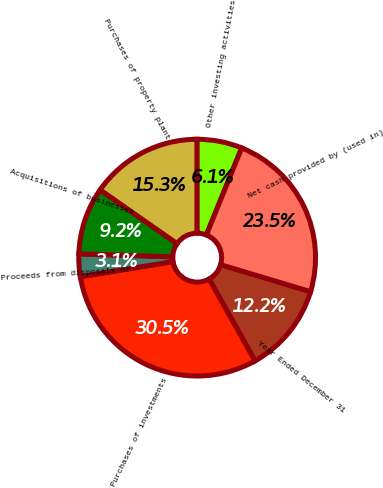Convert chart. <chart><loc_0><loc_0><loc_500><loc_500><pie_chart><fcel>Year Ended December 31<fcel>Purchases of investments<fcel>Proceeds from disposals of<fcel>Acquisitions of businesses<fcel>Purchases of property plant<fcel>Other investing activities<fcel>Net cash provided by (used in)<nl><fcel>12.24%<fcel>30.54%<fcel>3.09%<fcel>9.19%<fcel>15.29%<fcel>6.14%<fcel>23.5%<nl></chart> 